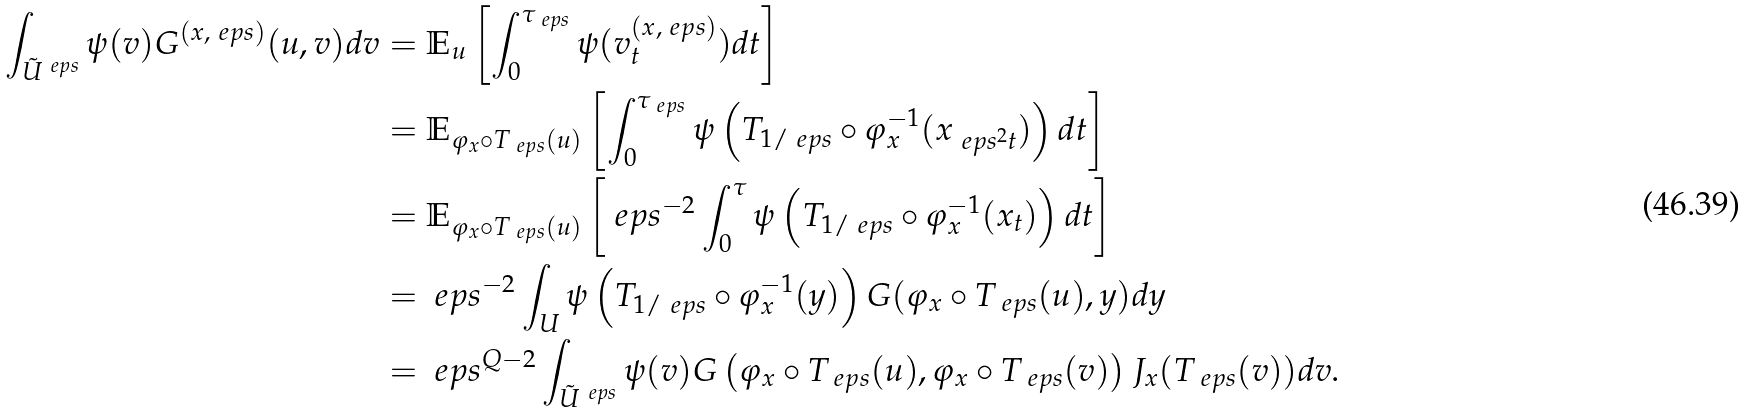Convert formula to latex. <formula><loc_0><loc_0><loc_500><loc_500>\int _ { \tilde { U } ^ { \ e p s } } \psi ( v ) G ^ { ( x , \ e p s ) } ( u , v ) d v & = \mathbb { E } _ { u } \left [ \int _ { 0 } ^ { \tau _ { \ e p s } } \psi ( v ^ { ( x , \ e p s ) } _ { t } ) d t \right ] \\ & = \mathbb { E } _ { \varphi _ { x } \circ T _ { \ e p s } ( u ) } \left [ \int _ { 0 } ^ { \tau _ { \ e p s } } \psi \left ( T _ { 1 / \ e p s } \circ \varphi _ { x } ^ { - 1 } ( x _ { \ e p s ^ { 2 } t } ) \right ) d t \right ] \\ & = \mathbb { E } _ { \varphi _ { x } \circ T _ { \ e p s } ( u ) } \left [ \ e p s ^ { - 2 } \int _ { 0 } ^ { \tau } \psi \left ( T _ { 1 / \ e p s } \circ \varphi _ { x } ^ { - 1 } ( x _ { t } ) \right ) d t \right ] \\ & = \ e p s ^ { - 2 } \int _ { U } \psi \left ( T _ { 1 / \ e p s } \circ \varphi _ { x } ^ { - 1 } ( y ) \right ) G ( \varphi _ { x } \circ T _ { \ e p s } ( u ) , y ) d y \\ & = \ e p s ^ { Q - 2 } \int _ { \tilde { U } ^ { \ e p s } } \psi ( v ) G \left ( \varphi _ { x } \circ T _ { \ e p s } ( u ) , \varphi _ { x } \circ T _ { \ e p s } ( v ) \right ) J _ { x } ( T _ { \ e p s } ( v ) ) d v .</formula> 